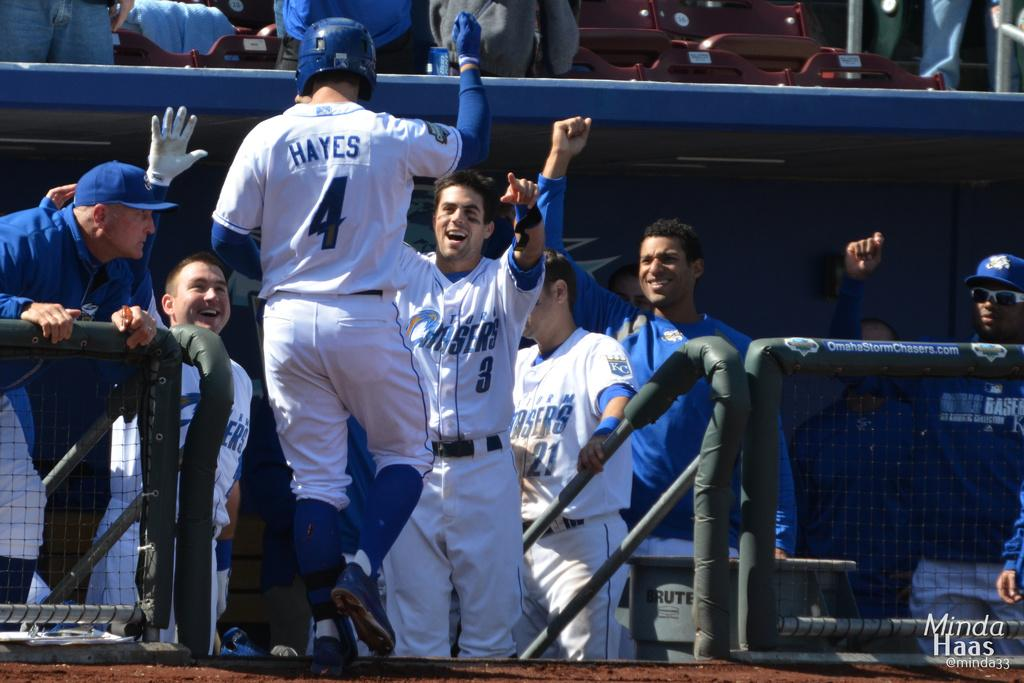<image>
Create a compact narrative representing the image presented. A baseball player with a uniform that says Hayes is joining his teammates in the dug out. 